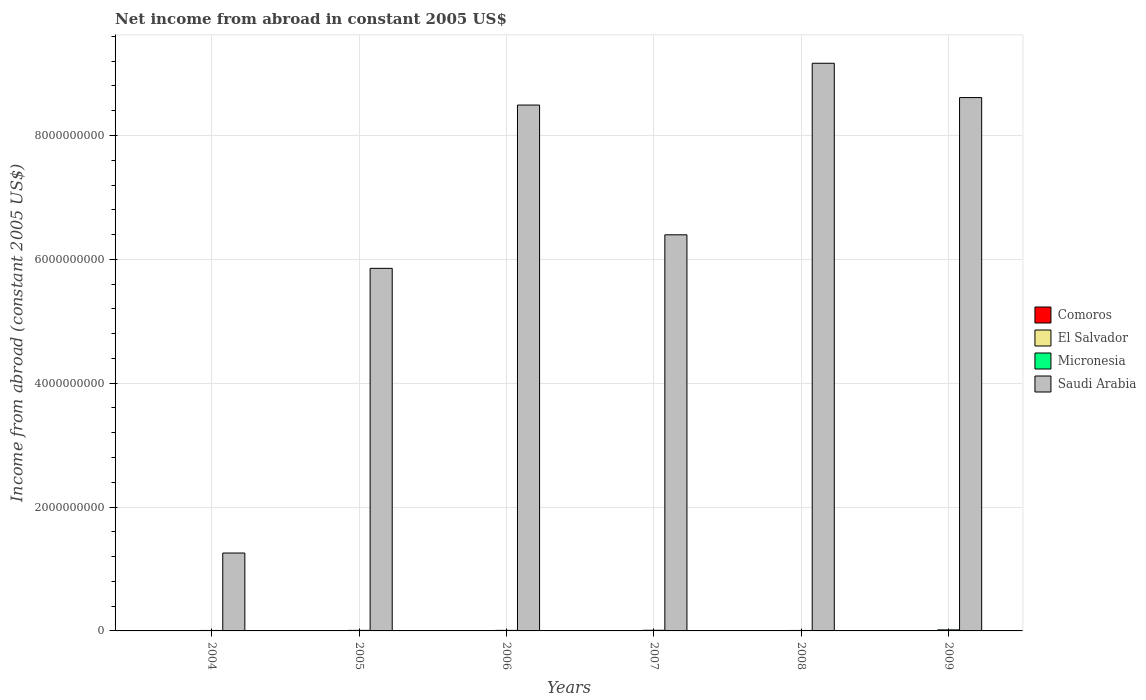How many different coloured bars are there?
Give a very brief answer. 2. How many groups of bars are there?
Your response must be concise. 6. Are the number of bars per tick equal to the number of legend labels?
Give a very brief answer. No. Are the number of bars on each tick of the X-axis equal?
Offer a terse response. Yes. How many bars are there on the 5th tick from the left?
Your answer should be very brief. 2. What is the label of the 4th group of bars from the left?
Your answer should be compact. 2007. In how many cases, is the number of bars for a given year not equal to the number of legend labels?
Your answer should be compact. 6. What is the net income from abroad in Micronesia in 2009?
Keep it short and to the point. 1.69e+07. Across all years, what is the maximum net income from abroad in Saudi Arabia?
Provide a succinct answer. 9.17e+09. What is the difference between the net income from abroad in Micronesia in 2007 and that in 2009?
Provide a short and direct response. -6.37e+06. What is the difference between the net income from abroad in Micronesia in 2006 and the net income from abroad in El Salvador in 2004?
Your answer should be very brief. 8.72e+06. In the year 2006, what is the difference between the net income from abroad in Micronesia and net income from abroad in Saudi Arabia?
Your answer should be very brief. -8.48e+09. In how many years, is the net income from abroad in Comoros greater than 6800000000 US$?
Provide a succinct answer. 0. What is the ratio of the net income from abroad in Micronesia in 2004 to that in 2008?
Your response must be concise. 1.01. Is the difference between the net income from abroad in Micronesia in 2004 and 2009 greater than the difference between the net income from abroad in Saudi Arabia in 2004 and 2009?
Your answer should be compact. Yes. What is the difference between the highest and the second highest net income from abroad in Saudi Arabia?
Offer a very short reply. 5.54e+08. What is the difference between the highest and the lowest net income from abroad in Micronesia?
Offer a terse response. 9.50e+06. In how many years, is the net income from abroad in Saudi Arabia greater than the average net income from abroad in Saudi Arabia taken over all years?
Your answer should be very brief. 3. Where does the legend appear in the graph?
Your answer should be compact. Center right. How are the legend labels stacked?
Ensure brevity in your answer.  Vertical. What is the title of the graph?
Your answer should be very brief. Net income from abroad in constant 2005 US$. What is the label or title of the X-axis?
Provide a succinct answer. Years. What is the label or title of the Y-axis?
Keep it short and to the point. Income from abroad (constant 2005 US$). What is the Income from abroad (constant 2005 US$) of Micronesia in 2004?
Offer a very short reply. 7.45e+06. What is the Income from abroad (constant 2005 US$) of Saudi Arabia in 2004?
Make the answer very short. 1.26e+09. What is the Income from abroad (constant 2005 US$) in Micronesia in 2005?
Give a very brief answer. 8.75e+06. What is the Income from abroad (constant 2005 US$) of Saudi Arabia in 2005?
Ensure brevity in your answer.  5.86e+09. What is the Income from abroad (constant 2005 US$) in Comoros in 2006?
Offer a very short reply. 0. What is the Income from abroad (constant 2005 US$) in El Salvador in 2006?
Your response must be concise. 0. What is the Income from abroad (constant 2005 US$) in Micronesia in 2006?
Keep it short and to the point. 8.72e+06. What is the Income from abroad (constant 2005 US$) of Saudi Arabia in 2006?
Make the answer very short. 8.49e+09. What is the Income from abroad (constant 2005 US$) of Comoros in 2007?
Provide a short and direct response. 0. What is the Income from abroad (constant 2005 US$) of Micronesia in 2007?
Keep it short and to the point. 1.05e+07. What is the Income from abroad (constant 2005 US$) of Saudi Arabia in 2007?
Provide a short and direct response. 6.40e+09. What is the Income from abroad (constant 2005 US$) in El Salvador in 2008?
Your answer should be compact. 0. What is the Income from abroad (constant 2005 US$) in Micronesia in 2008?
Ensure brevity in your answer.  7.36e+06. What is the Income from abroad (constant 2005 US$) in Saudi Arabia in 2008?
Offer a very short reply. 9.17e+09. What is the Income from abroad (constant 2005 US$) of Comoros in 2009?
Provide a short and direct response. 0. What is the Income from abroad (constant 2005 US$) in El Salvador in 2009?
Ensure brevity in your answer.  0. What is the Income from abroad (constant 2005 US$) in Micronesia in 2009?
Your answer should be compact. 1.69e+07. What is the Income from abroad (constant 2005 US$) of Saudi Arabia in 2009?
Keep it short and to the point. 8.61e+09. Across all years, what is the maximum Income from abroad (constant 2005 US$) of Micronesia?
Your answer should be compact. 1.69e+07. Across all years, what is the maximum Income from abroad (constant 2005 US$) of Saudi Arabia?
Offer a terse response. 9.17e+09. Across all years, what is the minimum Income from abroad (constant 2005 US$) in Micronesia?
Offer a terse response. 7.36e+06. Across all years, what is the minimum Income from abroad (constant 2005 US$) in Saudi Arabia?
Make the answer very short. 1.26e+09. What is the total Income from abroad (constant 2005 US$) of Micronesia in the graph?
Your answer should be very brief. 5.96e+07. What is the total Income from abroad (constant 2005 US$) in Saudi Arabia in the graph?
Keep it short and to the point. 3.98e+1. What is the difference between the Income from abroad (constant 2005 US$) in Micronesia in 2004 and that in 2005?
Your answer should be very brief. -1.30e+06. What is the difference between the Income from abroad (constant 2005 US$) in Saudi Arabia in 2004 and that in 2005?
Your answer should be compact. -4.60e+09. What is the difference between the Income from abroad (constant 2005 US$) in Micronesia in 2004 and that in 2006?
Your answer should be very brief. -1.27e+06. What is the difference between the Income from abroad (constant 2005 US$) in Saudi Arabia in 2004 and that in 2006?
Ensure brevity in your answer.  -7.23e+09. What is the difference between the Income from abroad (constant 2005 US$) of Micronesia in 2004 and that in 2007?
Ensure brevity in your answer.  -3.04e+06. What is the difference between the Income from abroad (constant 2005 US$) in Saudi Arabia in 2004 and that in 2007?
Give a very brief answer. -5.14e+09. What is the difference between the Income from abroad (constant 2005 US$) of Micronesia in 2004 and that in 2008?
Make the answer very short. 8.80e+04. What is the difference between the Income from abroad (constant 2005 US$) in Saudi Arabia in 2004 and that in 2008?
Your answer should be very brief. -7.91e+09. What is the difference between the Income from abroad (constant 2005 US$) of Micronesia in 2004 and that in 2009?
Your answer should be very brief. -9.41e+06. What is the difference between the Income from abroad (constant 2005 US$) in Saudi Arabia in 2004 and that in 2009?
Offer a terse response. -7.36e+09. What is the difference between the Income from abroad (constant 2005 US$) in Micronesia in 2005 and that in 2006?
Keep it short and to the point. 2.88e+04. What is the difference between the Income from abroad (constant 2005 US$) of Saudi Arabia in 2005 and that in 2006?
Keep it short and to the point. -2.64e+09. What is the difference between the Income from abroad (constant 2005 US$) in Micronesia in 2005 and that in 2007?
Give a very brief answer. -1.74e+06. What is the difference between the Income from abroad (constant 2005 US$) in Saudi Arabia in 2005 and that in 2007?
Your answer should be compact. -5.42e+08. What is the difference between the Income from abroad (constant 2005 US$) in Micronesia in 2005 and that in 2008?
Make the answer very short. 1.39e+06. What is the difference between the Income from abroad (constant 2005 US$) of Saudi Arabia in 2005 and that in 2008?
Offer a terse response. -3.31e+09. What is the difference between the Income from abroad (constant 2005 US$) in Micronesia in 2005 and that in 2009?
Make the answer very short. -8.11e+06. What is the difference between the Income from abroad (constant 2005 US$) of Saudi Arabia in 2005 and that in 2009?
Keep it short and to the point. -2.76e+09. What is the difference between the Income from abroad (constant 2005 US$) of Micronesia in 2006 and that in 2007?
Provide a succinct answer. -1.77e+06. What is the difference between the Income from abroad (constant 2005 US$) in Saudi Arabia in 2006 and that in 2007?
Ensure brevity in your answer.  2.10e+09. What is the difference between the Income from abroad (constant 2005 US$) of Micronesia in 2006 and that in 2008?
Offer a terse response. 1.36e+06. What is the difference between the Income from abroad (constant 2005 US$) of Saudi Arabia in 2006 and that in 2008?
Make the answer very short. -6.75e+08. What is the difference between the Income from abroad (constant 2005 US$) of Micronesia in 2006 and that in 2009?
Your answer should be compact. -8.14e+06. What is the difference between the Income from abroad (constant 2005 US$) of Saudi Arabia in 2006 and that in 2009?
Offer a very short reply. -1.21e+08. What is the difference between the Income from abroad (constant 2005 US$) of Micronesia in 2007 and that in 2008?
Offer a very short reply. 3.13e+06. What is the difference between the Income from abroad (constant 2005 US$) in Saudi Arabia in 2007 and that in 2008?
Make the answer very short. -2.77e+09. What is the difference between the Income from abroad (constant 2005 US$) in Micronesia in 2007 and that in 2009?
Keep it short and to the point. -6.37e+06. What is the difference between the Income from abroad (constant 2005 US$) of Saudi Arabia in 2007 and that in 2009?
Give a very brief answer. -2.22e+09. What is the difference between the Income from abroad (constant 2005 US$) in Micronesia in 2008 and that in 2009?
Provide a succinct answer. -9.50e+06. What is the difference between the Income from abroad (constant 2005 US$) in Saudi Arabia in 2008 and that in 2009?
Offer a very short reply. 5.54e+08. What is the difference between the Income from abroad (constant 2005 US$) in Micronesia in 2004 and the Income from abroad (constant 2005 US$) in Saudi Arabia in 2005?
Provide a short and direct response. -5.85e+09. What is the difference between the Income from abroad (constant 2005 US$) of Micronesia in 2004 and the Income from abroad (constant 2005 US$) of Saudi Arabia in 2006?
Your answer should be compact. -8.48e+09. What is the difference between the Income from abroad (constant 2005 US$) of Micronesia in 2004 and the Income from abroad (constant 2005 US$) of Saudi Arabia in 2007?
Provide a short and direct response. -6.39e+09. What is the difference between the Income from abroad (constant 2005 US$) of Micronesia in 2004 and the Income from abroad (constant 2005 US$) of Saudi Arabia in 2008?
Give a very brief answer. -9.16e+09. What is the difference between the Income from abroad (constant 2005 US$) of Micronesia in 2004 and the Income from abroad (constant 2005 US$) of Saudi Arabia in 2009?
Keep it short and to the point. -8.61e+09. What is the difference between the Income from abroad (constant 2005 US$) in Micronesia in 2005 and the Income from abroad (constant 2005 US$) in Saudi Arabia in 2006?
Your answer should be compact. -8.48e+09. What is the difference between the Income from abroad (constant 2005 US$) in Micronesia in 2005 and the Income from abroad (constant 2005 US$) in Saudi Arabia in 2007?
Make the answer very short. -6.39e+09. What is the difference between the Income from abroad (constant 2005 US$) in Micronesia in 2005 and the Income from abroad (constant 2005 US$) in Saudi Arabia in 2008?
Provide a succinct answer. -9.16e+09. What is the difference between the Income from abroad (constant 2005 US$) of Micronesia in 2005 and the Income from abroad (constant 2005 US$) of Saudi Arabia in 2009?
Make the answer very short. -8.60e+09. What is the difference between the Income from abroad (constant 2005 US$) of Micronesia in 2006 and the Income from abroad (constant 2005 US$) of Saudi Arabia in 2007?
Your response must be concise. -6.39e+09. What is the difference between the Income from abroad (constant 2005 US$) of Micronesia in 2006 and the Income from abroad (constant 2005 US$) of Saudi Arabia in 2008?
Ensure brevity in your answer.  -9.16e+09. What is the difference between the Income from abroad (constant 2005 US$) of Micronesia in 2006 and the Income from abroad (constant 2005 US$) of Saudi Arabia in 2009?
Make the answer very short. -8.60e+09. What is the difference between the Income from abroad (constant 2005 US$) of Micronesia in 2007 and the Income from abroad (constant 2005 US$) of Saudi Arabia in 2008?
Offer a terse response. -9.16e+09. What is the difference between the Income from abroad (constant 2005 US$) in Micronesia in 2007 and the Income from abroad (constant 2005 US$) in Saudi Arabia in 2009?
Provide a short and direct response. -8.60e+09. What is the difference between the Income from abroad (constant 2005 US$) of Micronesia in 2008 and the Income from abroad (constant 2005 US$) of Saudi Arabia in 2009?
Your answer should be very brief. -8.61e+09. What is the average Income from abroad (constant 2005 US$) of Comoros per year?
Your response must be concise. 0. What is the average Income from abroad (constant 2005 US$) of Micronesia per year?
Keep it short and to the point. 9.94e+06. What is the average Income from abroad (constant 2005 US$) of Saudi Arabia per year?
Offer a terse response. 6.63e+09. In the year 2004, what is the difference between the Income from abroad (constant 2005 US$) of Micronesia and Income from abroad (constant 2005 US$) of Saudi Arabia?
Provide a short and direct response. -1.25e+09. In the year 2005, what is the difference between the Income from abroad (constant 2005 US$) in Micronesia and Income from abroad (constant 2005 US$) in Saudi Arabia?
Offer a very short reply. -5.85e+09. In the year 2006, what is the difference between the Income from abroad (constant 2005 US$) in Micronesia and Income from abroad (constant 2005 US$) in Saudi Arabia?
Keep it short and to the point. -8.48e+09. In the year 2007, what is the difference between the Income from abroad (constant 2005 US$) in Micronesia and Income from abroad (constant 2005 US$) in Saudi Arabia?
Offer a terse response. -6.39e+09. In the year 2008, what is the difference between the Income from abroad (constant 2005 US$) in Micronesia and Income from abroad (constant 2005 US$) in Saudi Arabia?
Offer a very short reply. -9.16e+09. In the year 2009, what is the difference between the Income from abroad (constant 2005 US$) of Micronesia and Income from abroad (constant 2005 US$) of Saudi Arabia?
Offer a very short reply. -8.60e+09. What is the ratio of the Income from abroad (constant 2005 US$) in Micronesia in 2004 to that in 2005?
Make the answer very short. 0.85. What is the ratio of the Income from abroad (constant 2005 US$) in Saudi Arabia in 2004 to that in 2005?
Make the answer very short. 0.21. What is the ratio of the Income from abroad (constant 2005 US$) of Micronesia in 2004 to that in 2006?
Make the answer very short. 0.85. What is the ratio of the Income from abroad (constant 2005 US$) in Saudi Arabia in 2004 to that in 2006?
Offer a terse response. 0.15. What is the ratio of the Income from abroad (constant 2005 US$) of Micronesia in 2004 to that in 2007?
Provide a succinct answer. 0.71. What is the ratio of the Income from abroad (constant 2005 US$) of Saudi Arabia in 2004 to that in 2007?
Offer a terse response. 0.2. What is the ratio of the Income from abroad (constant 2005 US$) of Micronesia in 2004 to that in 2008?
Make the answer very short. 1.01. What is the ratio of the Income from abroad (constant 2005 US$) in Saudi Arabia in 2004 to that in 2008?
Offer a very short reply. 0.14. What is the ratio of the Income from abroad (constant 2005 US$) of Micronesia in 2004 to that in 2009?
Provide a succinct answer. 0.44. What is the ratio of the Income from abroad (constant 2005 US$) in Saudi Arabia in 2004 to that in 2009?
Ensure brevity in your answer.  0.15. What is the ratio of the Income from abroad (constant 2005 US$) in Micronesia in 2005 to that in 2006?
Your answer should be compact. 1. What is the ratio of the Income from abroad (constant 2005 US$) of Saudi Arabia in 2005 to that in 2006?
Your answer should be very brief. 0.69. What is the ratio of the Income from abroad (constant 2005 US$) in Micronesia in 2005 to that in 2007?
Give a very brief answer. 0.83. What is the ratio of the Income from abroad (constant 2005 US$) in Saudi Arabia in 2005 to that in 2007?
Keep it short and to the point. 0.92. What is the ratio of the Income from abroad (constant 2005 US$) in Micronesia in 2005 to that in 2008?
Keep it short and to the point. 1.19. What is the ratio of the Income from abroad (constant 2005 US$) of Saudi Arabia in 2005 to that in 2008?
Offer a terse response. 0.64. What is the ratio of the Income from abroad (constant 2005 US$) of Micronesia in 2005 to that in 2009?
Give a very brief answer. 0.52. What is the ratio of the Income from abroad (constant 2005 US$) in Saudi Arabia in 2005 to that in 2009?
Offer a very short reply. 0.68. What is the ratio of the Income from abroad (constant 2005 US$) in Micronesia in 2006 to that in 2007?
Your response must be concise. 0.83. What is the ratio of the Income from abroad (constant 2005 US$) of Saudi Arabia in 2006 to that in 2007?
Provide a short and direct response. 1.33. What is the ratio of the Income from abroad (constant 2005 US$) in Micronesia in 2006 to that in 2008?
Ensure brevity in your answer.  1.19. What is the ratio of the Income from abroad (constant 2005 US$) in Saudi Arabia in 2006 to that in 2008?
Keep it short and to the point. 0.93. What is the ratio of the Income from abroad (constant 2005 US$) in Micronesia in 2006 to that in 2009?
Your answer should be compact. 0.52. What is the ratio of the Income from abroad (constant 2005 US$) in Micronesia in 2007 to that in 2008?
Provide a short and direct response. 1.42. What is the ratio of the Income from abroad (constant 2005 US$) in Saudi Arabia in 2007 to that in 2008?
Ensure brevity in your answer.  0.7. What is the ratio of the Income from abroad (constant 2005 US$) in Micronesia in 2007 to that in 2009?
Your answer should be very brief. 0.62. What is the ratio of the Income from abroad (constant 2005 US$) of Saudi Arabia in 2007 to that in 2009?
Give a very brief answer. 0.74. What is the ratio of the Income from abroad (constant 2005 US$) in Micronesia in 2008 to that in 2009?
Your answer should be very brief. 0.44. What is the ratio of the Income from abroad (constant 2005 US$) of Saudi Arabia in 2008 to that in 2009?
Keep it short and to the point. 1.06. What is the difference between the highest and the second highest Income from abroad (constant 2005 US$) of Micronesia?
Provide a succinct answer. 6.37e+06. What is the difference between the highest and the second highest Income from abroad (constant 2005 US$) of Saudi Arabia?
Keep it short and to the point. 5.54e+08. What is the difference between the highest and the lowest Income from abroad (constant 2005 US$) of Micronesia?
Ensure brevity in your answer.  9.50e+06. What is the difference between the highest and the lowest Income from abroad (constant 2005 US$) of Saudi Arabia?
Provide a short and direct response. 7.91e+09. 